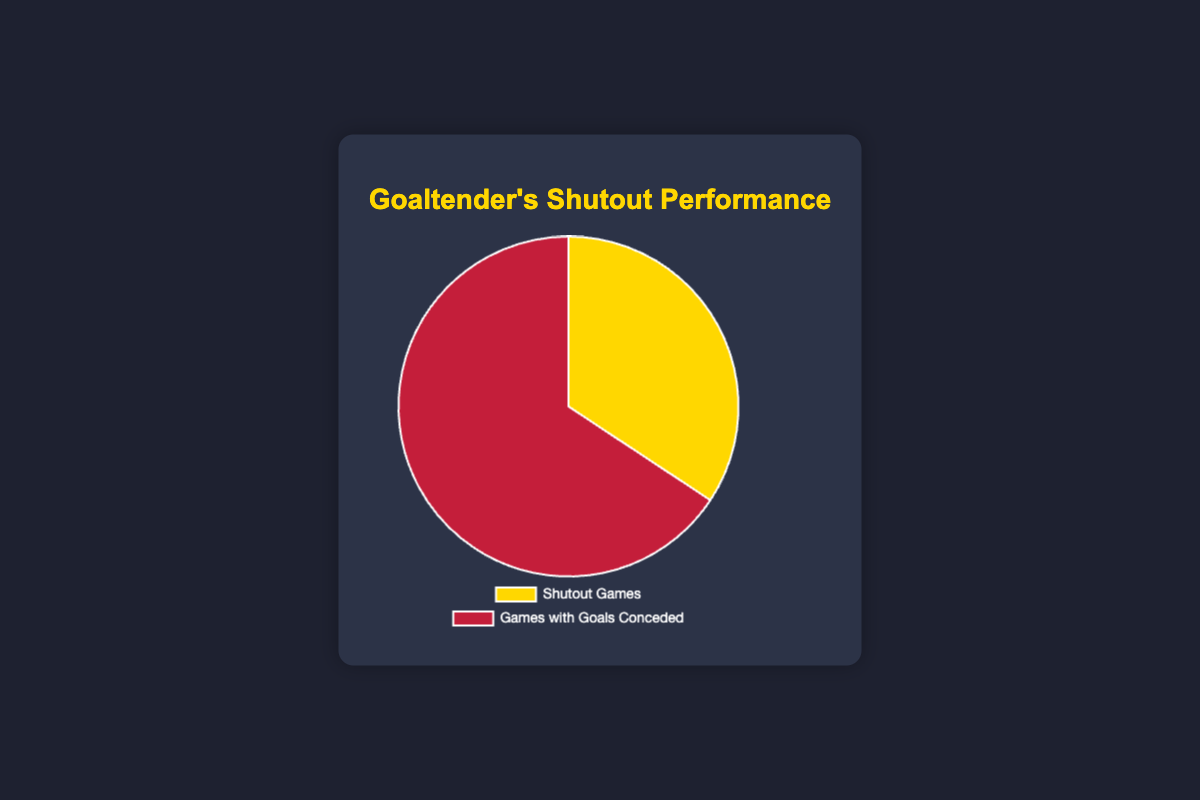What's the total number of games played by the young goaltender? To find the total, sum up the number of shutout games and games with goals conceded. 12 (shutout games) + 23 (games with goals conceded) = 35 games.
Answer: 35 Which type of game had more instances: Shutout Games or Games with Goals Conceded? Compare the two values: there are 12 shutout games and 23 games with goals conceded. Since 23 is greater than 12, there are more games with goals conceded.
Answer: Games with Goals Conceded By what number do the Games with Goals Conceded exceed the Shutout Games? To find the difference, subtract the number of shutout games from the number of games with goals conceded. 23 - 12 = 11.
Answer: 11 What is the ratio of Shutout Games to Games with Goals Conceded? To find the ratio, divide the number of shutout games by the number of games with goals conceded. The ratio is 12/23, which simplifies to approximately 0.52.
Answer: 0.52 Which segment in the pie chart is larger and what color is it? Visually identify the larger segment. The segment representing Games with Goals Conceded is larger and it is represented by the color red.
Answer: Red What percentage of the games were Shutout Games? To find the percentage, divide the number of shutout games by the total number of games and multiply by 100. (12 / 35) * 100 ≈ 34.29%.
Answer: 34.29% If the goaltender wants to achieve an equal number of shutout games and games with goals conceded, how many additional shutout games are needed? To have an equal number of both types, shutout games need to match games with goals conceded (23). Currently, there are 12 shutout games, so 23 - 12 = 11 more shutout games are needed.
Answer: 11 What is the average number of games per type (Shutout Games and Games with Goals Conceded)? To find the average, sum the number of shutout games and games with goals conceded and divide by 2. (12 + 23) / 2 = 17.5 games.
Answer: 17.5 What fraction of the total games are Games with Goals Conceded? To find the fraction, divide the number of games with goals conceded by the total number of games. 23 / 35 = 0.6571, which can be expressed as approximately 65.71%.
Answer: 65.71% 